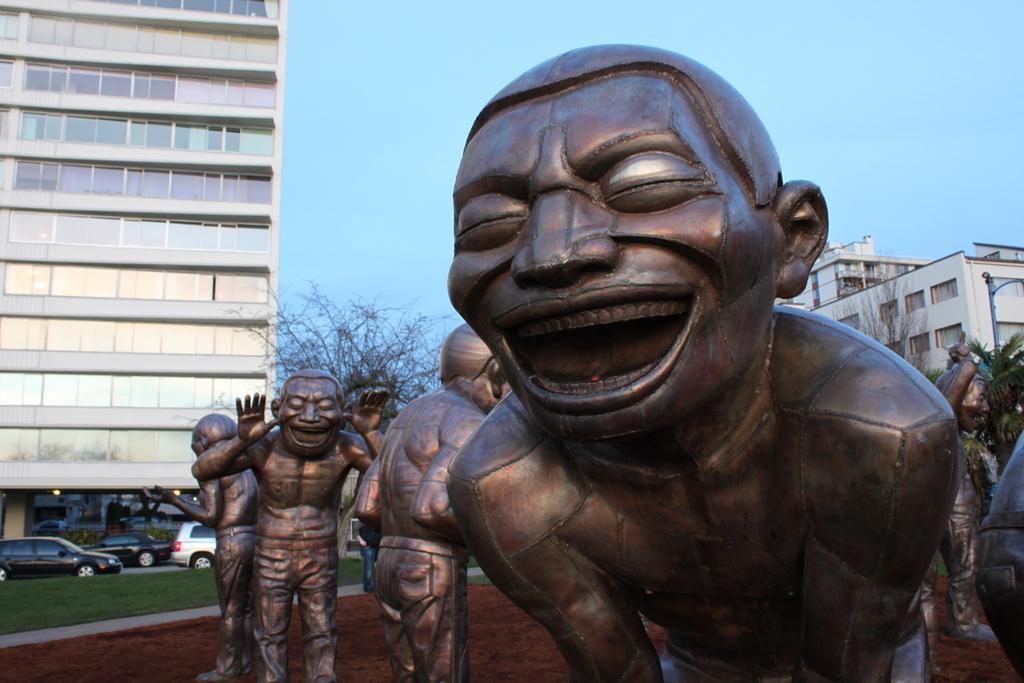Please provide a concise description of this image. In this image in front there are statues. At the bottom of the image there is grass on the surface. In the background of the image there are cars, trees, buildings and sky. 